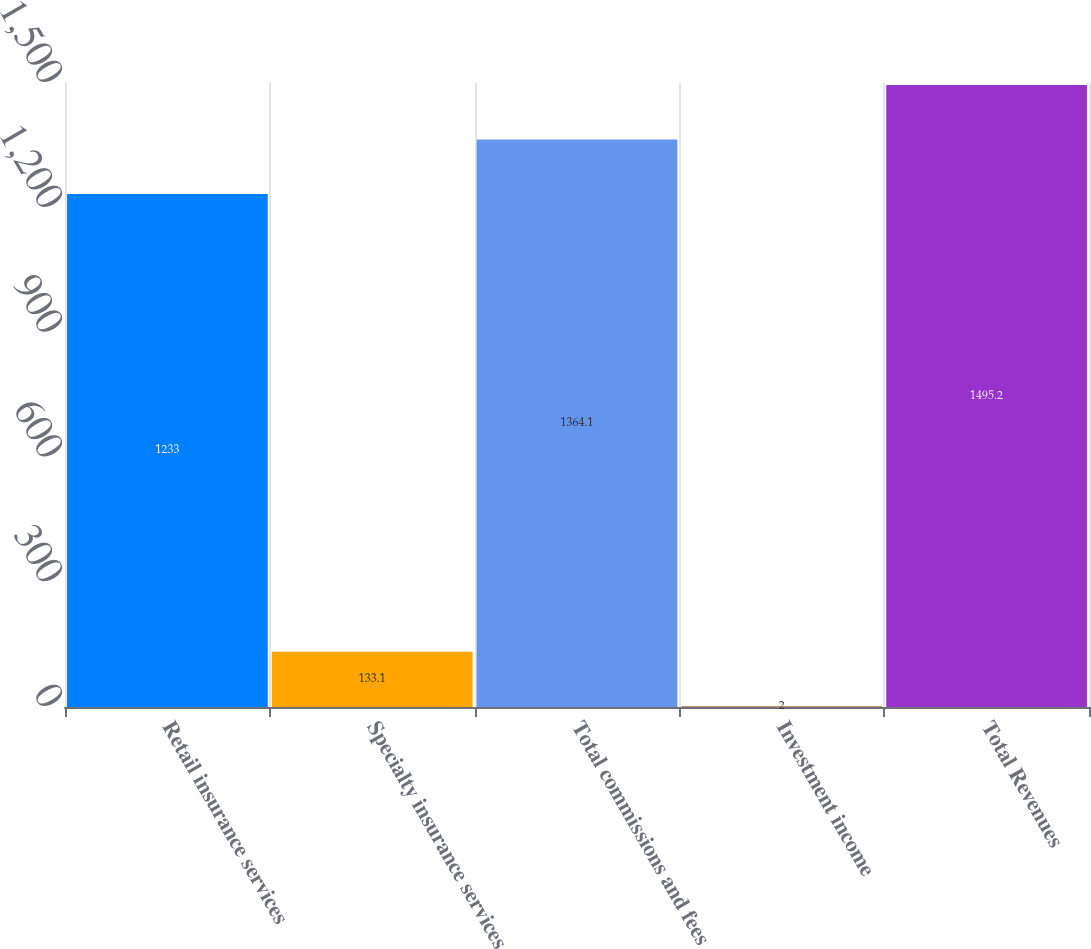Convert chart to OTSL. <chart><loc_0><loc_0><loc_500><loc_500><bar_chart><fcel>Retail insurance services<fcel>Specialty insurance services<fcel>Total commissions and fees<fcel>Investment income<fcel>Total Revenues<nl><fcel>1233<fcel>133.1<fcel>1364.1<fcel>2<fcel>1495.2<nl></chart> 